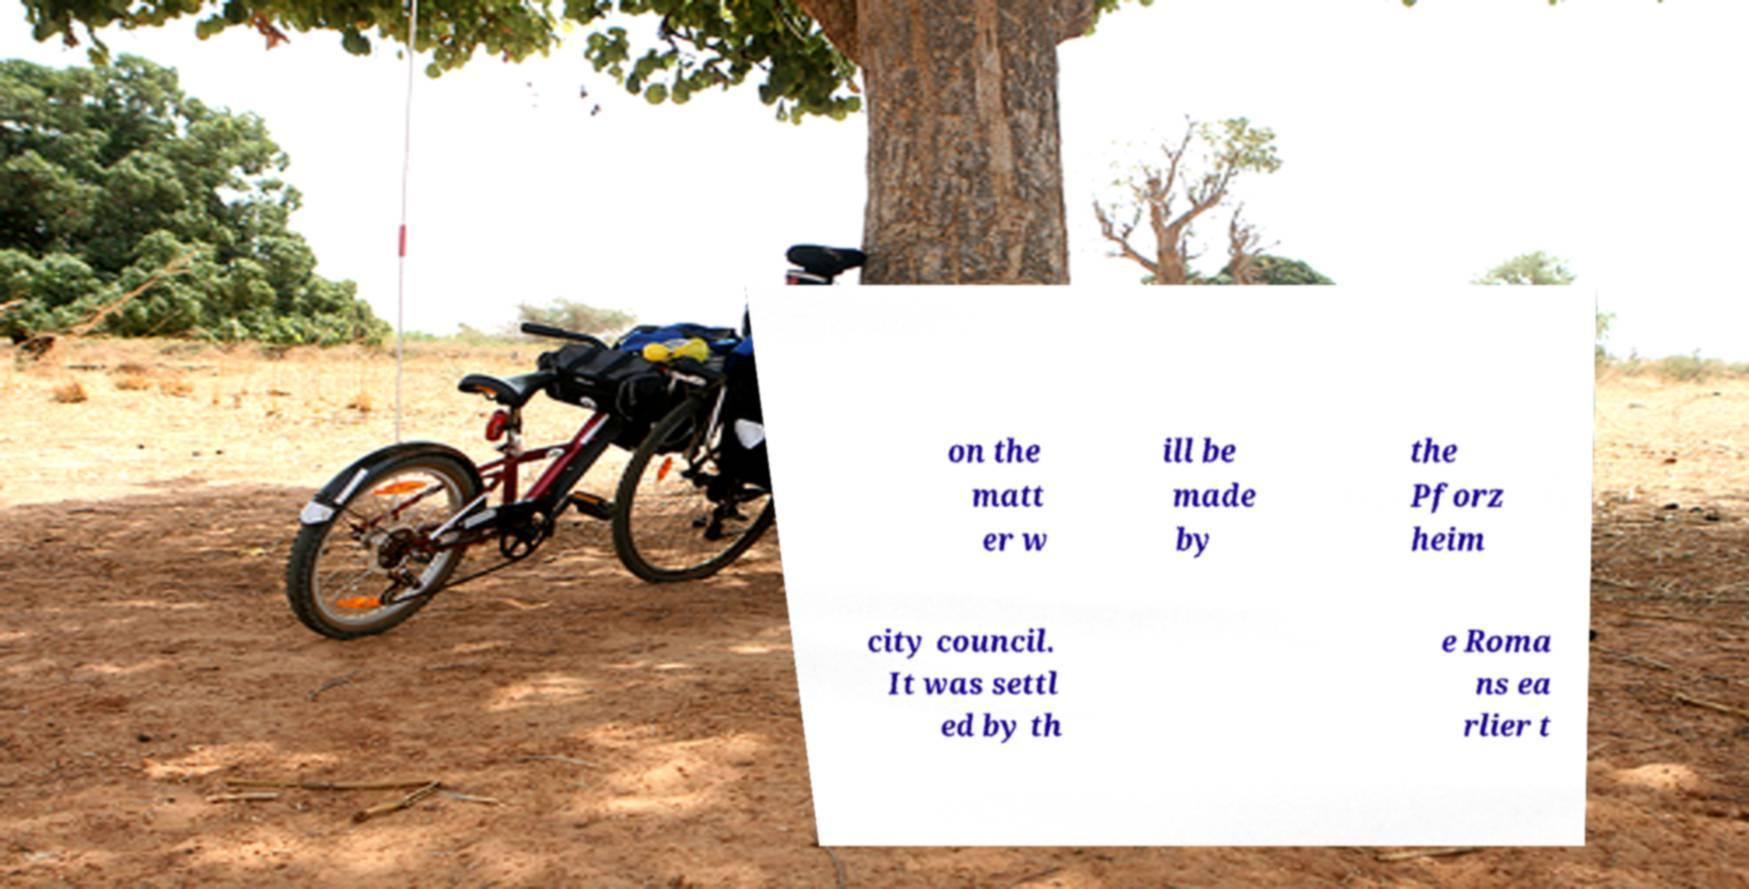For documentation purposes, I need the text within this image transcribed. Could you provide that? on the matt er w ill be made by the Pforz heim city council. It was settl ed by th e Roma ns ea rlier t 